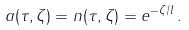Convert formula to latex. <formula><loc_0><loc_0><loc_500><loc_500>a ( \tau , \zeta ) = n ( \tau , \zeta ) = e ^ { - \zeta / l } \, .</formula> 